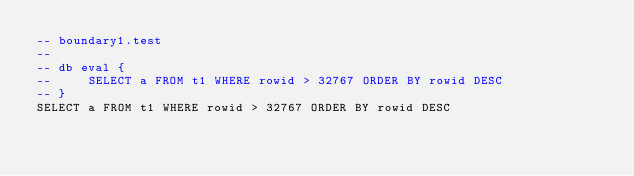Convert code to text. <code><loc_0><loc_0><loc_500><loc_500><_SQL_>-- boundary1.test
-- 
-- db eval {
--     SELECT a FROM t1 WHERE rowid > 32767 ORDER BY rowid DESC
-- }
SELECT a FROM t1 WHERE rowid > 32767 ORDER BY rowid DESC</code> 